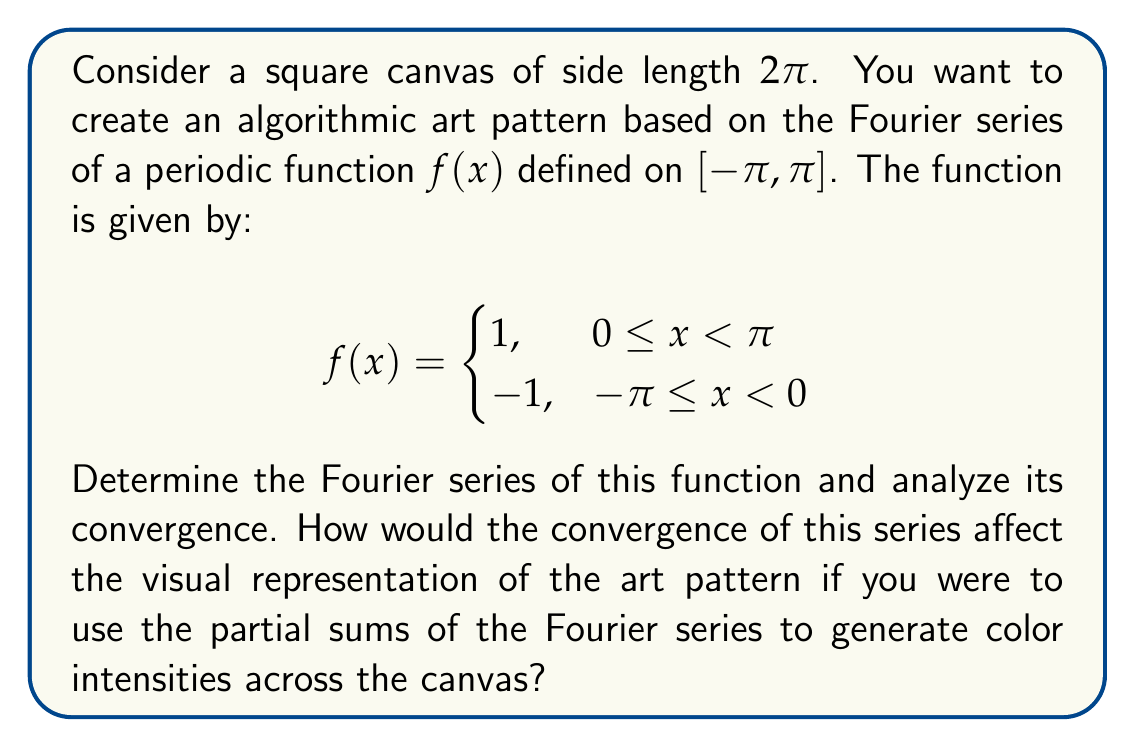Can you solve this math problem? Let's approach this step-by-step:

1) First, we need to find the Fourier series of the given function. The Fourier series of a function $f(x)$ on $[-\pi,\pi]$ is given by:

   $$f(x) \sim \frac{a_0}{2} + \sum_{n=1}^{\infty} (a_n \cos(nx) + b_n \sin(nx))$$

   where $a_n$ and $b_n$ are the Fourier coefficients.

2) For this function, due to its odd symmetry, all $a_n$ coefficients (including $a_0$) will be zero. We only need to calculate $b_n$.

3) The formula for $b_n$ is:

   $$b_n = \frac{1}{\pi} \int_{-\pi}^{\pi} f(x) \sin(nx) dx$$

4) Calculating $b_n$:

   $$\begin{align}
   b_n &= \frac{1}{\pi} \left(\int_{-\pi}^{0} (-1) \sin(nx) dx + \int_{0}^{\pi} 1 \sin(nx) dx\right) \\
   &= \frac{1}{\pi} \left(\frac{\cos(nx)}{n}\bigg|_{-\pi}^{0} - \frac{\cos(nx)}{n}\bigg|_{0}^{\pi}\right) \\
   &= \frac{1}{\pi n} (1 - \cos(n\pi) - 1 + \cos(n\pi)) \\
   &= \frac{2}{\pi n} (1 - \cos(n\pi)) \\
   &= \begin{cases}
      0, & \text{if n is even} \\
      \frac{4}{\pi n}, & \text{if n is odd}
      \end{cases}
   \end{align}$$

5) Therefore, the Fourier series of $f(x)$ is:

   $$f(x) \sim \frac{4}{\pi} \sum_{k=0}^{\infty} \frac{\sin((2k+1)x)}{2k+1}$$

6) To analyze convergence, we can use the Dirichlet-Jordan test. The function $f(x)$ is piecewise continuous and of bounded variation on $[-\pi,\pi]$. Therefore, the Fourier series converges to $f(x)$ at all points where $f(x)$ is continuous, and to the average of the left and right hand limits at discontinuities.

7) For the visual representation, the partial sums of the Fourier series would approximate the function $f(x)$ with increasing accuracy as more terms are included. However, near the discontinuities at $x=0$ and $x=\pm\pi$, there will always be some oscillation (known as the Gibbs phenomenon).

8) In terms of algorithmic art, this means:
   - The canvas would be divided into two halves vertically.
   - As more terms of the series are included, the division between the two halves would become sharper.
   - Near the division line, there would always be some "ringing" or oscillation in color intensity.
   - The left half would trend towards one color intensity (representing -1) and the right half towards another (representing 1).
Answer: The Fourier series of the given function is:

$$f(x) \sim \frac{4}{\pi} \sum_{k=0}^{\infty} \frac{\sin((2k+1)x)}{2k+1}$$

This series converges to $f(x)$ at all points where $f(x)$ is continuous, and to the average of the left and right hand limits at discontinuities. In an algorithmic art representation, this would create a sharp vertical division on the canvas with some persistent oscillation near the division line, becoming more pronounced as more terms of the series are included. 